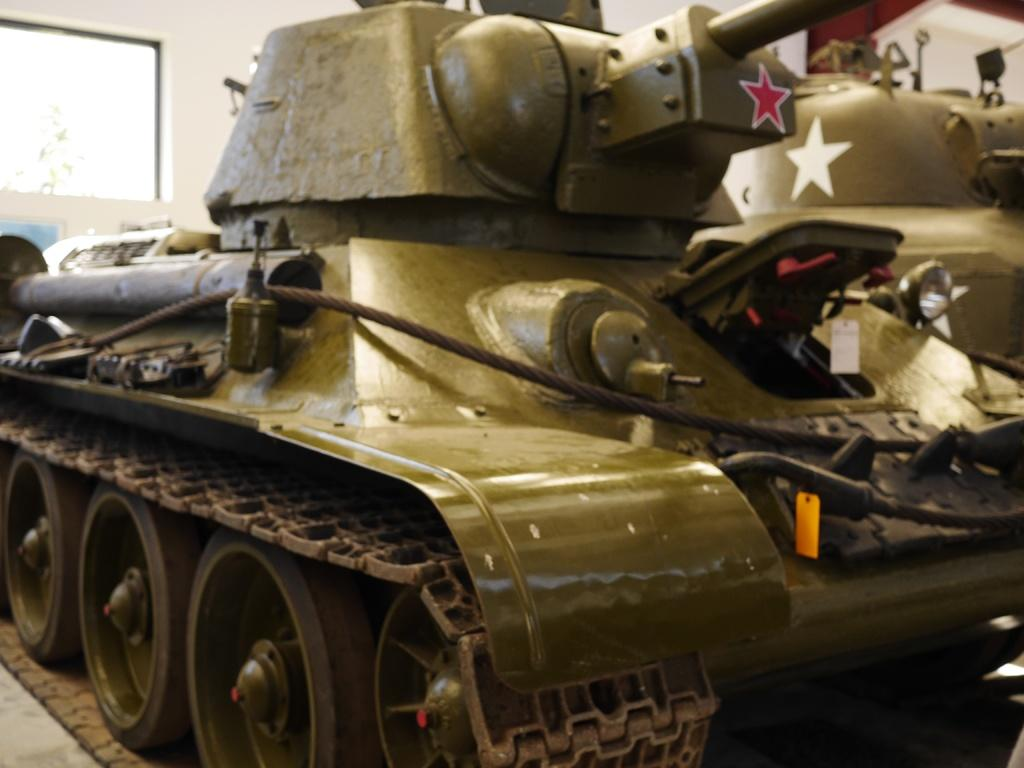What is the main subject of the image? The main subject of the image is a tank. What type of mitten is being used to aid in the digestion of the meal in the image? There is no mitten or meal present in the image; it only features a tank. 